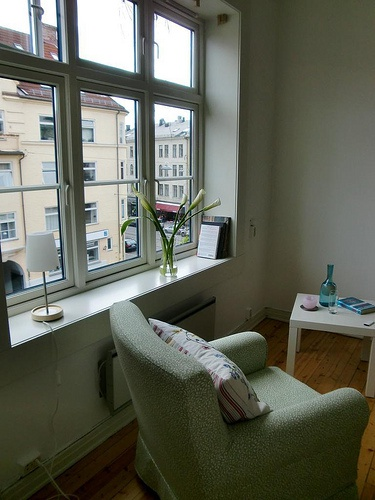Describe the objects in this image and their specific colors. I can see couch in white, black, darkgray, gray, and darkgreen tones, chair in white, black, darkgray, gray, and darkgreen tones, potted plant in white, black, darkgray, gray, and darkgreen tones, book in white, lightgray, darkgray, and gray tones, and vase in white, darkgray, darkgreen, and olive tones in this image. 